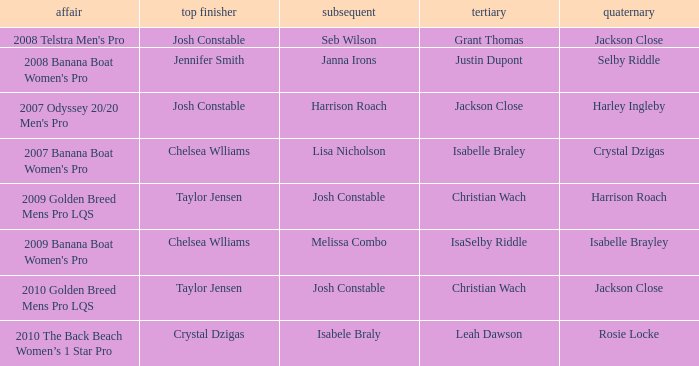Who was in Second Place with Isabelle Brayley came in Fourth? Melissa Combo. 